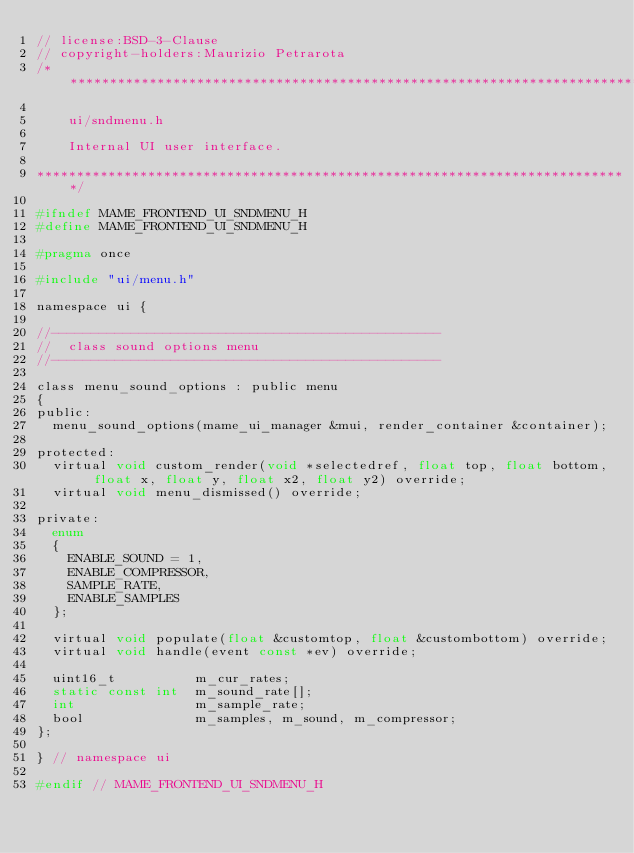Convert code to text. <code><loc_0><loc_0><loc_500><loc_500><_C_>// license:BSD-3-Clause
// copyright-holders:Maurizio Petrarota
/***************************************************************************

    ui/sndmenu.h

    Internal UI user interface.

***************************************************************************/

#ifndef MAME_FRONTEND_UI_SNDMENU_H
#define MAME_FRONTEND_UI_SNDMENU_H

#pragma once

#include "ui/menu.h"

namespace ui {

//-------------------------------------------------
//  class sound options menu
//-------------------------------------------------

class menu_sound_options : public menu
{
public:
	menu_sound_options(mame_ui_manager &mui, render_container &container);

protected:
	virtual void custom_render(void *selectedref, float top, float bottom, float x, float y, float x2, float y2) override;
	virtual void menu_dismissed() override;

private:
	enum
	{
		ENABLE_SOUND = 1,
		ENABLE_COMPRESSOR,
		SAMPLE_RATE,
		ENABLE_SAMPLES
	};

	virtual void populate(float &customtop, float &custombottom) override;
	virtual void handle(event const *ev) override;

	uint16_t          m_cur_rates;
	static const int  m_sound_rate[];
	int               m_sample_rate;
	bool              m_samples, m_sound, m_compressor;
};

} // namespace ui

#endif // MAME_FRONTEND_UI_SNDMENU_H
</code> 